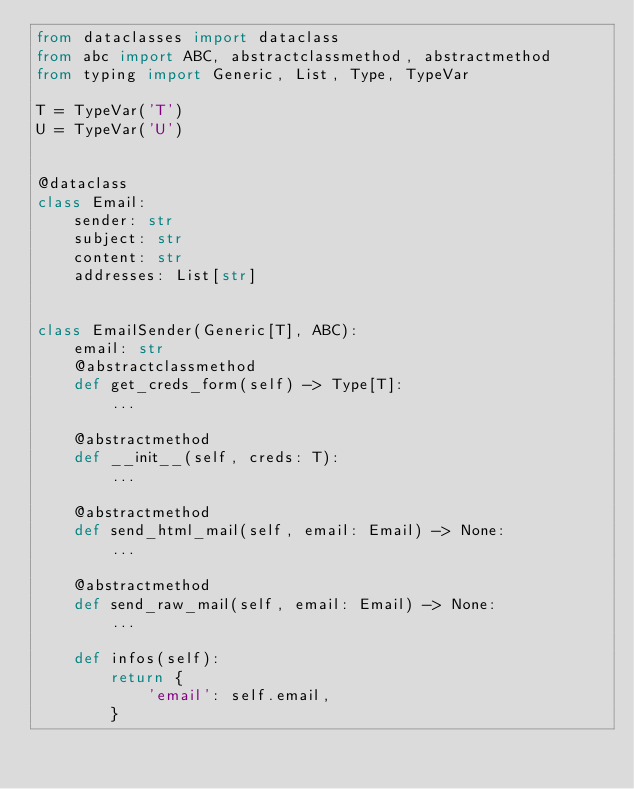<code> <loc_0><loc_0><loc_500><loc_500><_Python_>from dataclasses import dataclass
from abc import ABC, abstractclassmethod, abstractmethod
from typing import Generic, List, Type, TypeVar

T = TypeVar('T')
U = TypeVar('U')


@dataclass
class Email:
    sender: str
    subject: str
    content: str
    addresses: List[str]


class EmailSender(Generic[T], ABC):
    email: str
    @abstractclassmethod
    def get_creds_form(self) -> Type[T]:
        ...

    @abstractmethod
    def __init__(self, creds: T):
        ...

    @abstractmethod
    def send_html_mail(self, email: Email) -> None:
        ...

    @abstractmethod
    def send_raw_mail(self, email: Email) -> None:
        ...

    def infos(self):
        return {
            'email': self.email,
        }
</code> 